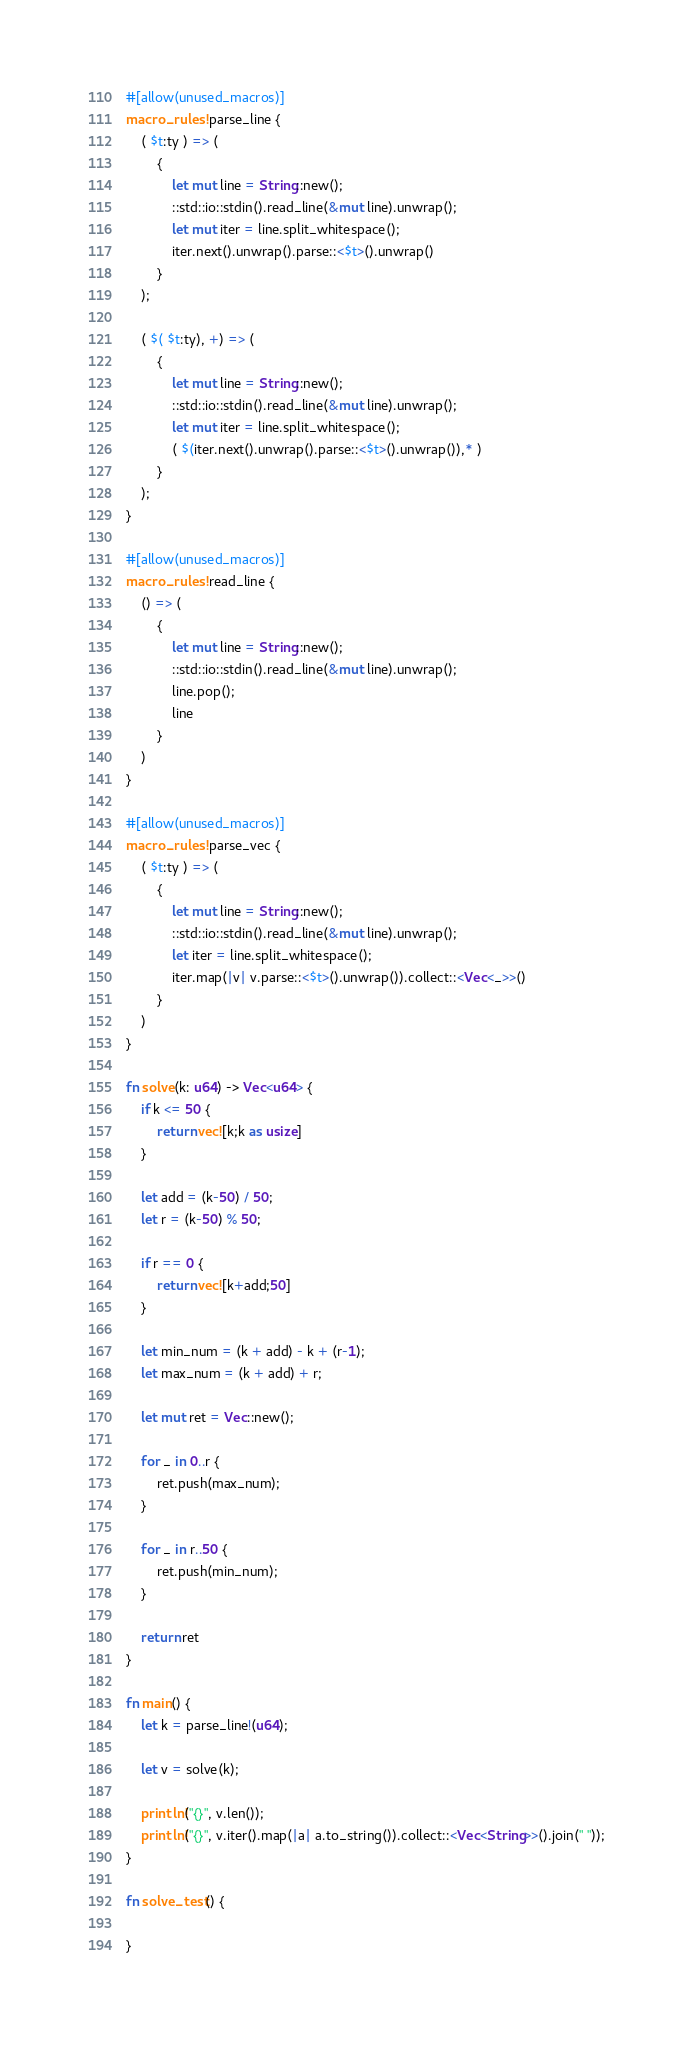<code> <loc_0><loc_0><loc_500><loc_500><_Rust_>#[allow(unused_macros)]
macro_rules! parse_line {
    ( $t:ty ) => (
        {
            let mut line = String::new();
            ::std::io::stdin().read_line(&mut line).unwrap();
            let mut iter = line.split_whitespace();
            iter.next().unwrap().parse::<$t>().unwrap()
        }
    );

    ( $( $t:ty), +) => (
        {
            let mut line = String::new();
            ::std::io::stdin().read_line(&mut line).unwrap();
            let mut iter = line.split_whitespace();
            ( $(iter.next().unwrap().parse::<$t>().unwrap()),* )
        }
    );
}

#[allow(unused_macros)]
macro_rules! read_line {
    () => (
        {
            let mut line = String::new();
            ::std::io::stdin().read_line(&mut line).unwrap();
            line.pop();
            line
        }
    )
}

#[allow(unused_macros)]
macro_rules! parse_vec {
    ( $t:ty ) => (
        {
            let mut line = String::new();
            ::std::io::stdin().read_line(&mut line).unwrap();
            let iter = line.split_whitespace();
            iter.map(|v| v.parse::<$t>().unwrap()).collect::<Vec<_>>()
        }
    )
}

fn solve(k: u64) -> Vec<u64> {
    if k <= 50 {
        return vec![k;k as usize]
    }

    let add = (k-50) / 50;
    let r = (k-50) % 50;

    if r == 0 {
        return vec![k+add;50]
    }

    let min_num = (k + add) - k + (r-1);
    let max_num = (k + add) + r;

    let mut ret = Vec::new();

    for _ in 0..r {
        ret.push(max_num);
    }

    for _ in r..50 {
        ret.push(min_num);
    }

    return ret
}

fn main() {
    let k = parse_line!(u64);

    let v = solve(k);

    println!("{}", v.len());
    println!("{}", v.iter().map(|a| a.to_string()).collect::<Vec<String>>().join(" "));
}

fn solve_test() {
    
}
</code> 